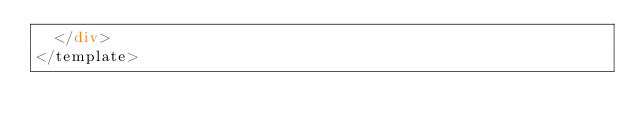Convert code to text. <code><loc_0><loc_0><loc_500><loc_500><_HTML_>  </div>
</template>
</code> 